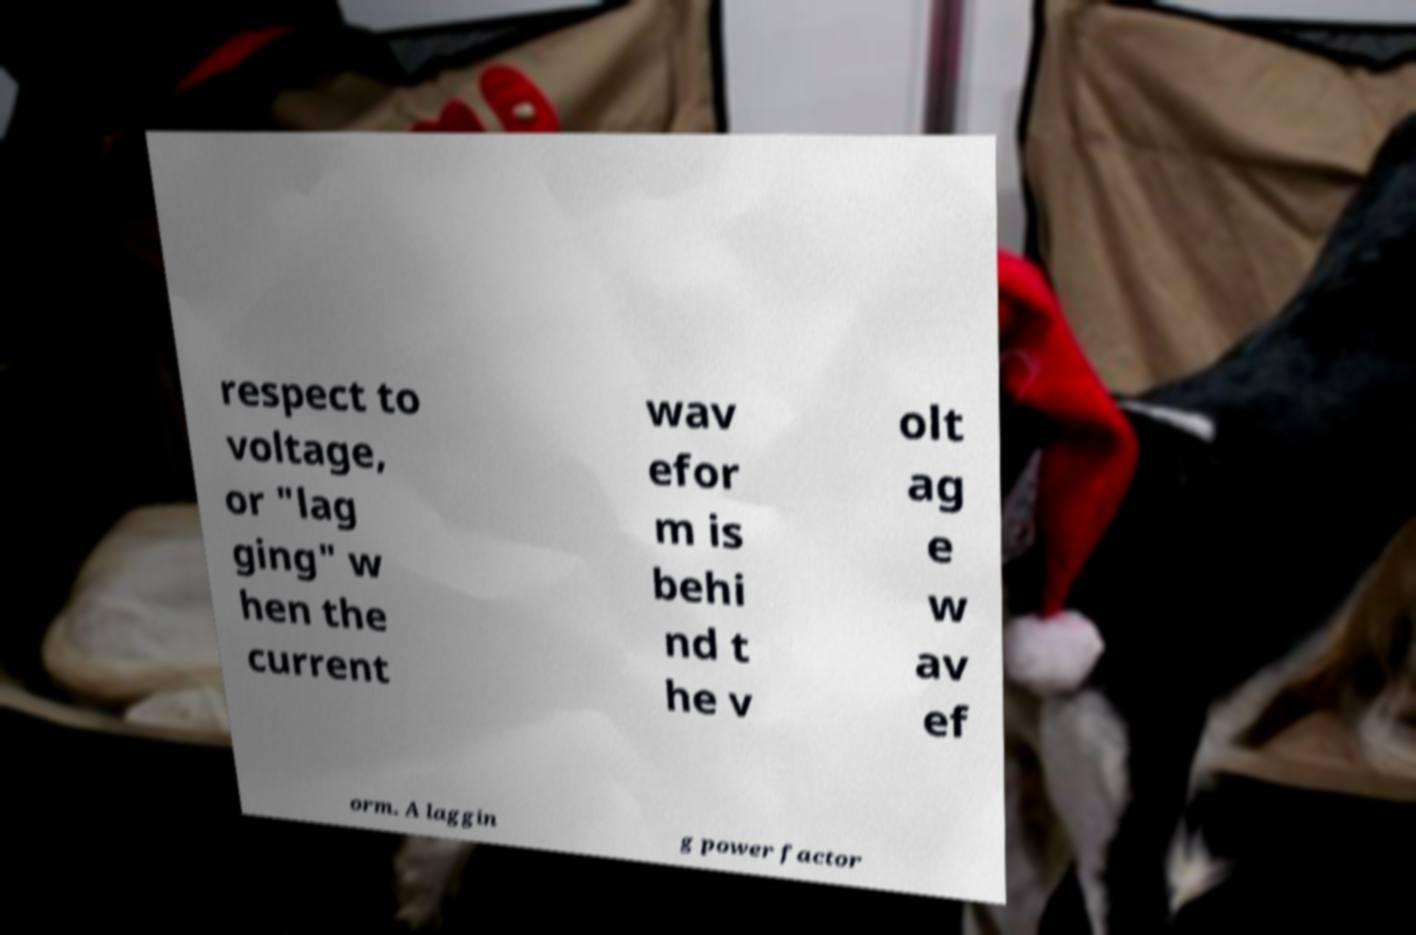There's text embedded in this image that I need extracted. Can you transcribe it verbatim? respect to voltage, or "lag ging" w hen the current wav efor m is behi nd t he v olt ag e w av ef orm. A laggin g power factor 